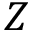Convert formula to latex. <formula><loc_0><loc_0><loc_500><loc_500>Z</formula> 